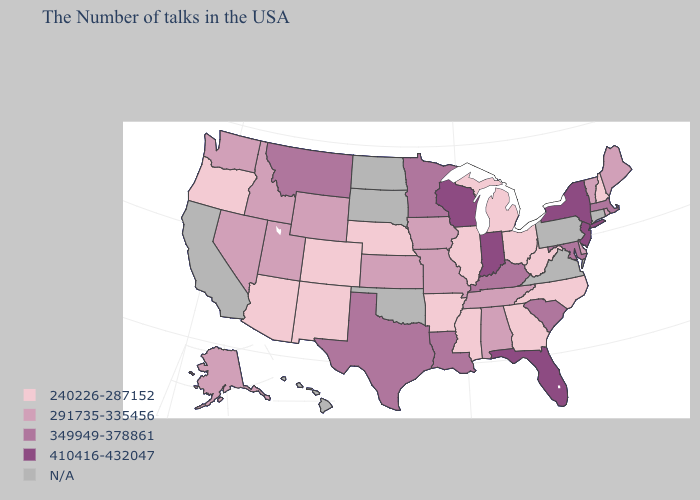Name the states that have a value in the range 291735-335456?
Keep it brief. Maine, Rhode Island, Vermont, Delaware, Alabama, Tennessee, Missouri, Iowa, Kansas, Wyoming, Utah, Idaho, Nevada, Washington, Alaska. Name the states that have a value in the range 291735-335456?
Give a very brief answer. Maine, Rhode Island, Vermont, Delaware, Alabama, Tennessee, Missouri, Iowa, Kansas, Wyoming, Utah, Idaho, Nevada, Washington, Alaska. Name the states that have a value in the range 291735-335456?
Keep it brief. Maine, Rhode Island, Vermont, Delaware, Alabama, Tennessee, Missouri, Iowa, Kansas, Wyoming, Utah, Idaho, Nevada, Washington, Alaska. Which states have the highest value in the USA?
Write a very short answer. New York, New Jersey, Florida, Indiana, Wisconsin. Which states have the highest value in the USA?
Give a very brief answer. New York, New Jersey, Florida, Indiana, Wisconsin. What is the highest value in the South ?
Write a very short answer. 410416-432047. What is the value of New York?
Give a very brief answer. 410416-432047. What is the value of Texas?
Give a very brief answer. 349949-378861. Name the states that have a value in the range 410416-432047?
Write a very short answer. New York, New Jersey, Florida, Indiana, Wisconsin. What is the value of New Mexico?
Quick response, please. 240226-287152. What is the value of Mississippi?
Keep it brief. 240226-287152. Name the states that have a value in the range 291735-335456?
Give a very brief answer. Maine, Rhode Island, Vermont, Delaware, Alabama, Tennessee, Missouri, Iowa, Kansas, Wyoming, Utah, Idaho, Nevada, Washington, Alaska. Does the first symbol in the legend represent the smallest category?
Short answer required. Yes. 